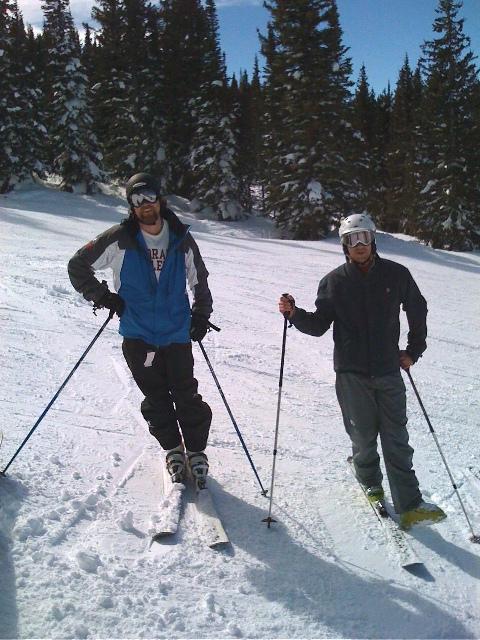What are the men standing in?
Be succinct. Snow. How deep is the snow?
Give a very brief answer. 3 feet. How many poles can be seen?
Be succinct. 4. Are there two adults?
Answer briefly. Yes. Are the men wearing sunglasses?
Write a very short answer. Yes. 